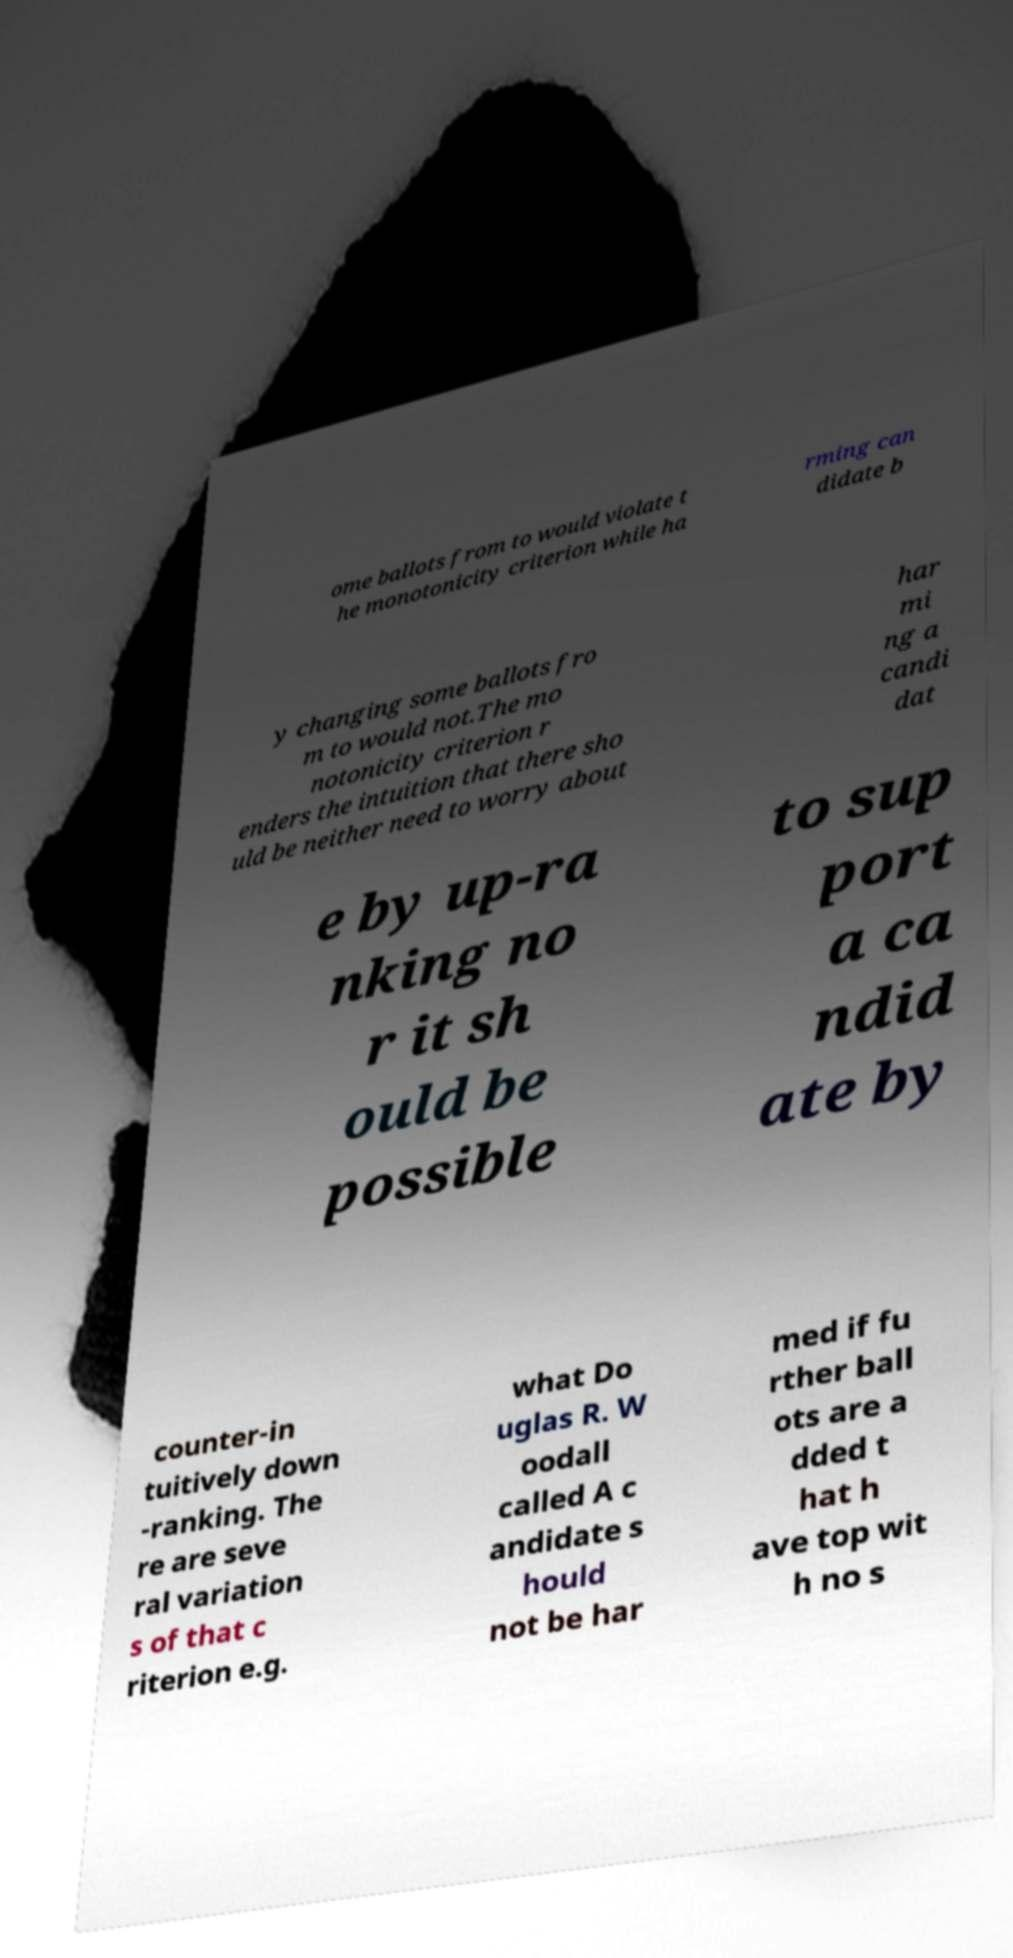There's text embedded in this image that I need extracted. Can you transcribe it verbatim? ome ballots from to would violate t he monotonicity criterion while ha rming can didate b y changing some ballots fro m to would not.The mo notonicity criterion r enders the intuition that there sho uld be neither need to worry about har mi ng a candi dat e by up-ra nking no r it sh ould be possible to sup port a ca ndid ate by counter-in tuitively down -ranking. The re are seve ral variation s of that c riterion e.g. what Do uglas R. W oodall called A c andidate s hould not be har med if fu rther ball ots are a dded t hat h ave top wit h no s 